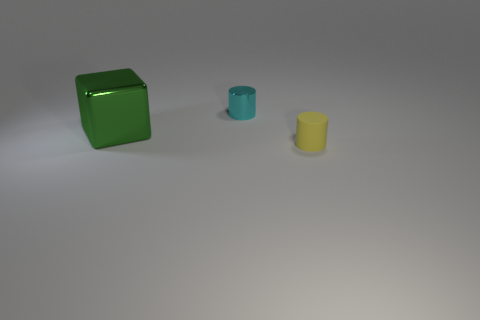Is there anything else that has the same material as the yellow object?
Provide a short and direct response. No. Is there a small yellow rubber object that has the same shape as the cyan metallic object?
Keep it short and to the point. Yes. How many objects are large blue shiny cubes or objects in front of the green metallic thing?
Provide a succinct answer. 1. There is a small thing that is behind the tiny matte cylinder; what color is it?
Offer a very short reply. Cyan. Do the cylinder behind the green cube and the object that is on the left side of the tiny shiny thing have the same size?
Your response must be concise. No. Is there a purple matte cylinder that has the same size as the yellow cylinder?
Your answer should be compact. No. How many big green metal objects are left of the cylinder that is behind the small yellow cylinder?
Provide a succinct answer. 1. What is the material of the cyan cylinder?
Offer a very short reply. Metal. There is a yellow thing; how many small matte cylinders are left of it?
Your answer should be very brief. 0. Is the color of the big metal thing the same as the tiny shiny cylinder?
Ensure brevity in your answer.  No. 